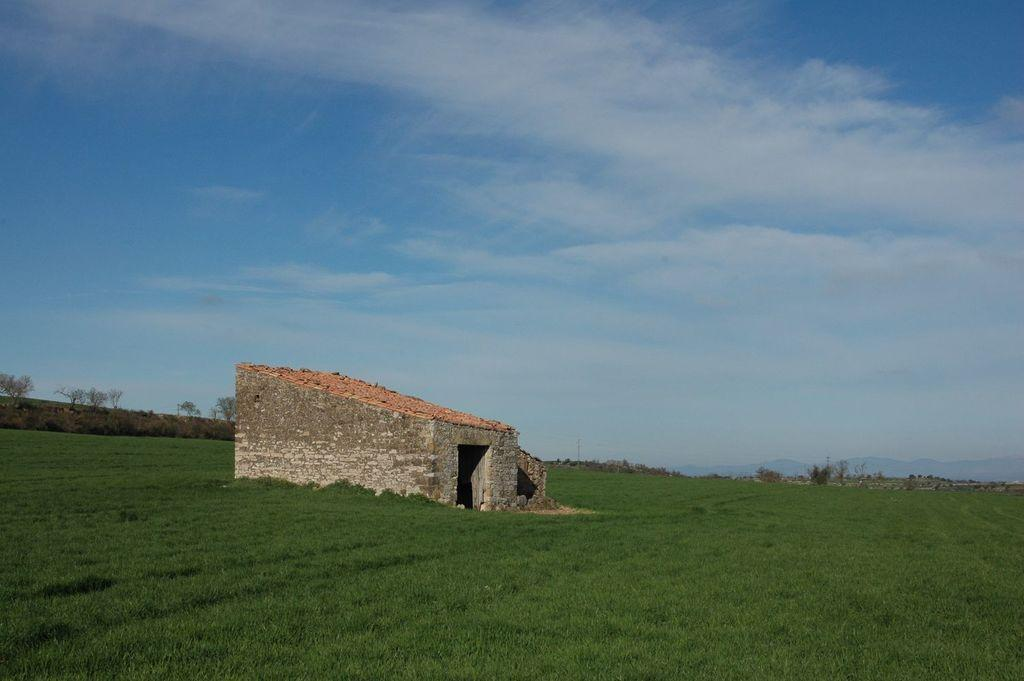What color are the grass and trees in the image? The grass and trees are in green color. What type of structure can be seen in the image? There is a house in the image. What colors are used for the house? The house is in cream and brown color. What can be seen in the background of the image? The sky is in blue and white color in the background. Can you taste the bone in the image? There is no bone present in the image, so it is not possible to taste it. 